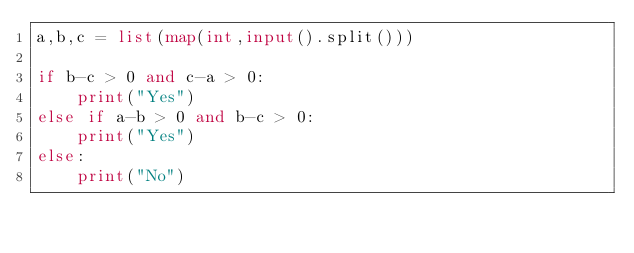Convert code to text. <code><loc_0><loc_0><loc_500><loc_500><_Python_>a,b,c = list(map(int,input().split()))

if b-c > 0 and c-a > 0:
    print("Yes")
else if a-b > 0 and b-c > 0:
    print("Yes")
else:
    print("No")</code> 